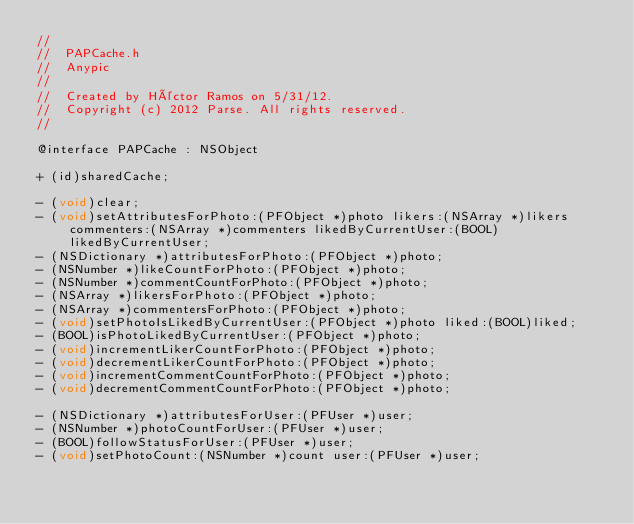Convert code to text. <code><loc_0><loc_0><loc_500><loc_500><_C_>//
//  PAPCache.h
//  Anypic
//
//  Created by Héctor Ramos on 5/31/12.
//  Copyright (c) 2012 Parse. All rights reserved.
//

@interface PAPCache : NSObject

+ (id)sharedCache;

- (void)clear;
- (void)setAttributesForPhoto:(PFObject *)photo likers:(NSArray *)likers commenters:(NSArray *)commenters likedByCurrentUser:(BOOL)likedByCurrentUser;
- (NSDictionary *)attributesForPhoto:(PFObject *)photo;
- (NSNumber *)likeCountForPhoto:(PFObject *)photo;
- (NSNumber *)commentCountForPhoto:(PFObject *)photo;
- (NSArray *)likersForPhoto:(PFObject *)photo;
- (NSArray *)commentersForPhoto:(PFObject *)photo;
- (void)setPhotoIsLikedByCurrentUser:(PFObject *)photo liked:(BOOL)liked;
- (BOOL)isPhotoLikedByCurrentUser:(PFObject *)photo;
- (void)incrementLikerCountForPhoto:(PFObject *)photo;
- (void)decrementLikerCountForPhoto:(PFObject *)photo;
- (void)incrementCommentCountForPhoto:(PFObject *)photo;
- (void)decrementCommentCountForPhoto:(PFObject *)photo;

- (NSDictionary *)attributesForUser:(PFUser *)user;
- (NSNumber *)photoCountForUser:(PFUser *)user;
- (BOOL)followStatusForUser:(PFUser *)user;
- (void)setPhotoCount:(NSNumber *)count user:(PFUser *)user;</code> 